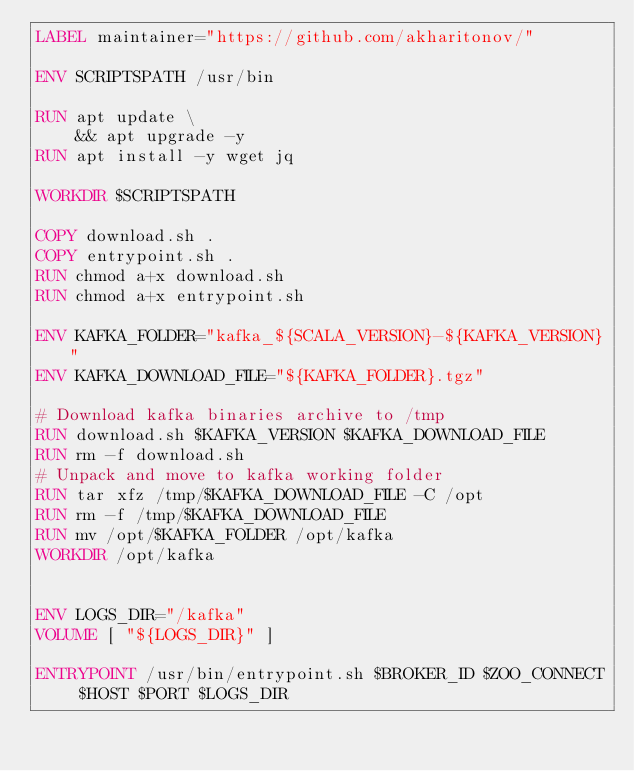Convert code to text. <code><loc_0><loc_0><loc_500><loc_500><_Dockerfile_>LABEL maintainer="https://github.com/akharitonov/"
 
ENV SCRIPTSPATH /usr/bin

RUN apt update \
    && apt upgrade -y
RUN apt install -y wget jq

WORKDIR $SCRIPTSPATH

COPY download.sh .
COPY entrypoint.sh .
RUN chmod a+x download.sh
RUN chmod a+x entrypoint.sh

ENV KAFKA_FOLDER="kafka_${SCALA_VERSION}-${KAFKA_VERSION}"
ENV KAFKA_DOWNLOAD_FILE="${KAFKA_FOLDER}.tgz"

# Download kafka binaries archive to /tmp
RUN download.sh $KAFKA_VERSION $KAFKA_DOWNLOAD_FILE
RUN rm -f download.sh
# Unpack and move to kafka working folder
RUN tar xfz /tmp/$KAFKA_DOWNLOAD_FILE -C /opt
RUN rm -f /tmp/$KAFKA_DOWNLOAD_FILE
RUN mv /opt/$KAFKA_FOLDER /opt/kafka
WORKDIR /opt/kafka


ENV LOGS_DIR="/kafka"
VOLUME [ "${LOGS_DIR}" ]

ENTRYPOINT /usr/bin/entrypoint.sh $BROKER_ID $ZOO_CONNECT $HOST $PORT $LOGS_DIR</code> 